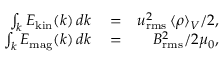Convert formula to latex. <formula><loc_0><loc_0><loc_500><loc_500>\begin{array} { r l r } { \int _ { k } E _ { k i n } ( k ) \, d k } & = } & { u _ { r m s } ^ { 2 } \, \langle \rho \rangle _ { V } / 2 , } \\ { \int _ { k } E _ { m a g } ( k ) \, d k } & = } & { B _ { r m s } ^ { 2 } / 2 \mu _ { 0 } , } \end{array}</formula> 